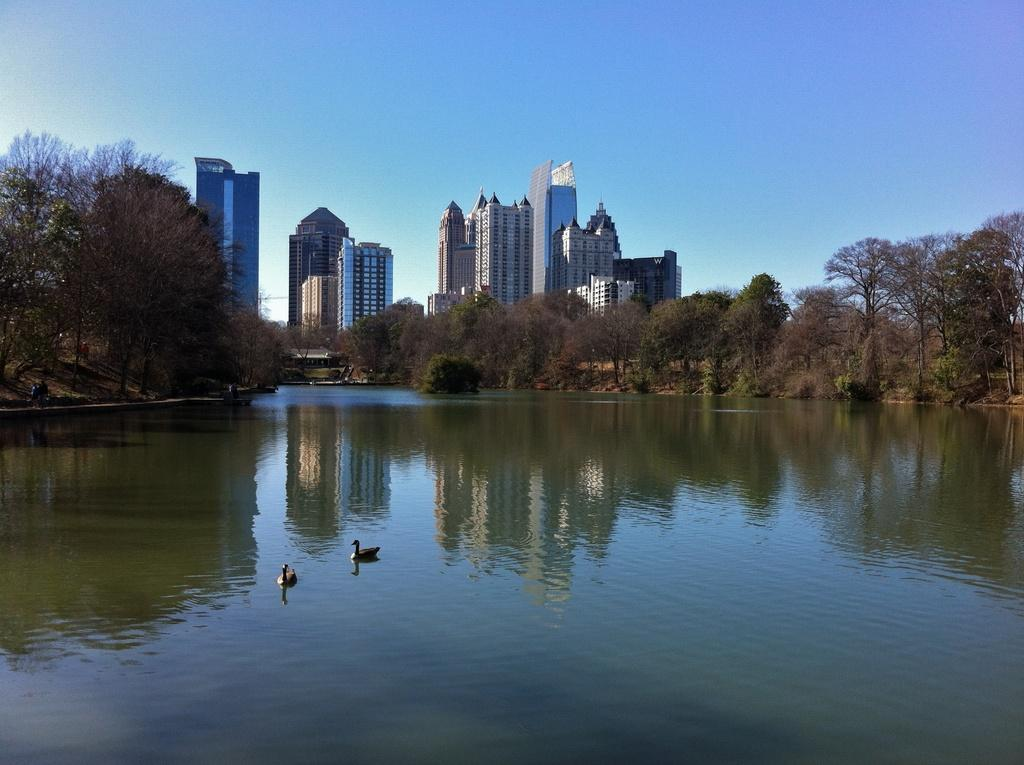What is located in the middle of the image? There is water in the middle of the image. What animals can be seen in the water? There are swans in the water. What type of vegetation is present in the image? There are trees in the image. What type of structures can be seen in the image? There are buildings in the image. What is visible at the top of the image? The sky is visible at the top of the image. Where is the basket located in the image? There is no basket present in the image. Can you see any clams in the water? There are no clams visible in the water; only swans can be seen. 